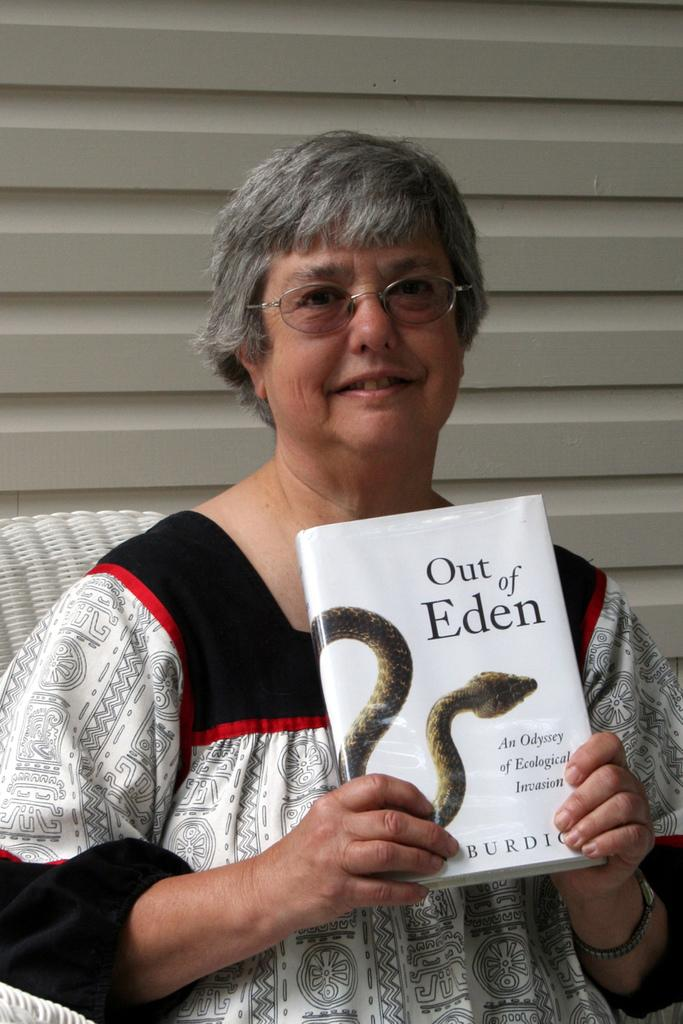Who is the main subject in the image? There is a woman in the image. Where is the woman located in the image? The woman is in the middle of the image. What is the woman holding in her hands? The woman is holding a book in her hands. What can be seen in the background of the image? There are window blinds visible in the background of the image. What are the woman's hobbies, as indicated by her expression in the image? There is no information about the woman's hobbies or expression in the image, so we cannot determine her hobbies from the image. 